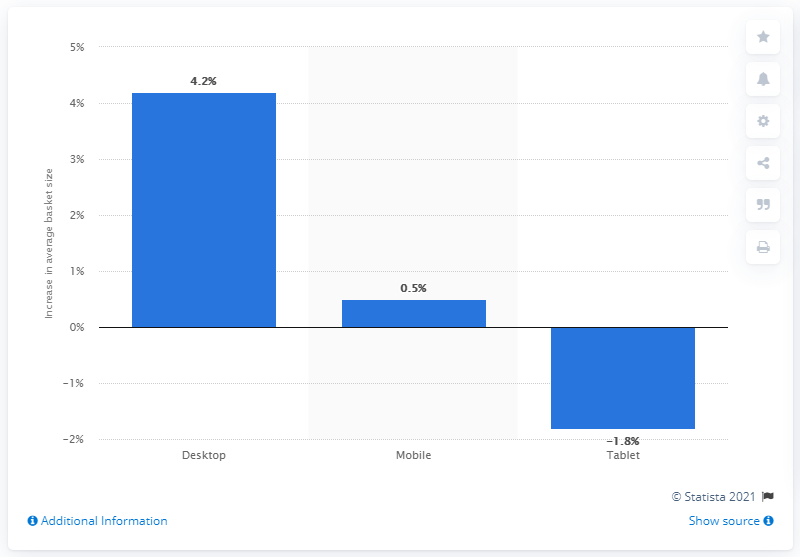Can you explain what the overall trend for device usage was from 2015 to 2016? Certainly! The bar chart shows that from 2015 to 2016, desktop computer usage increased by 4.2%, mobile device usage saw a slight uptick of 0.5%, while tablet device usage declined by 1.8%. This indicates a mixed trend with a notable increase in desktop usage and a decline in tablet popularity. 